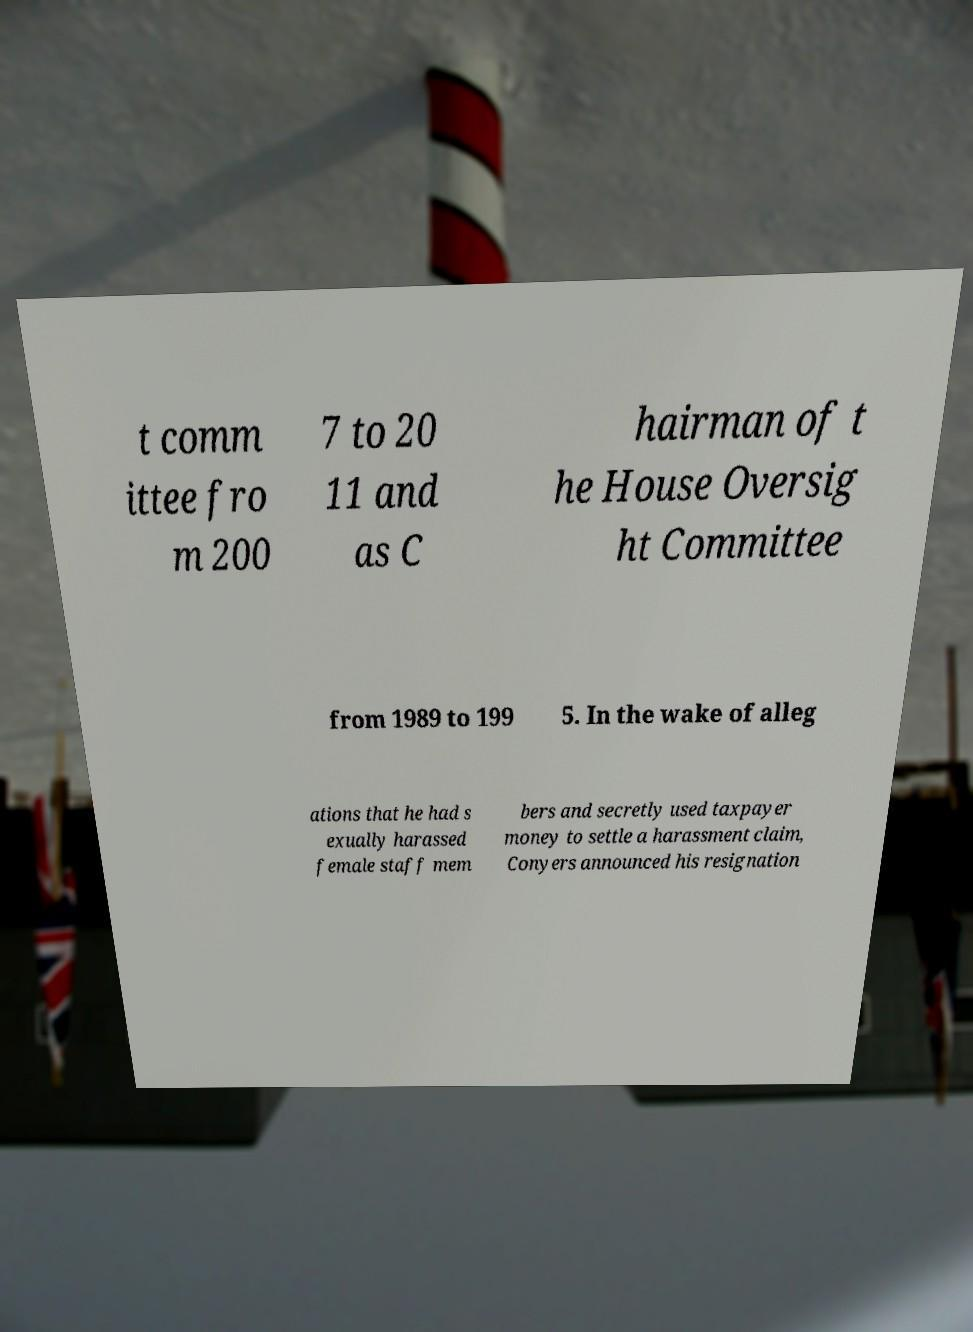Can you accurately transcribe the text from the provided image for me? t comm ittee fro m 200 7 to 20 11 and as C hairman of t he House Oversig ht Committee from 1989 to 199 5. In the wake of alleg ations that he had s exually harassed female staff mem bers and secretly used taxpayer money to settle a harassment claim, Conyers announced his resignation 